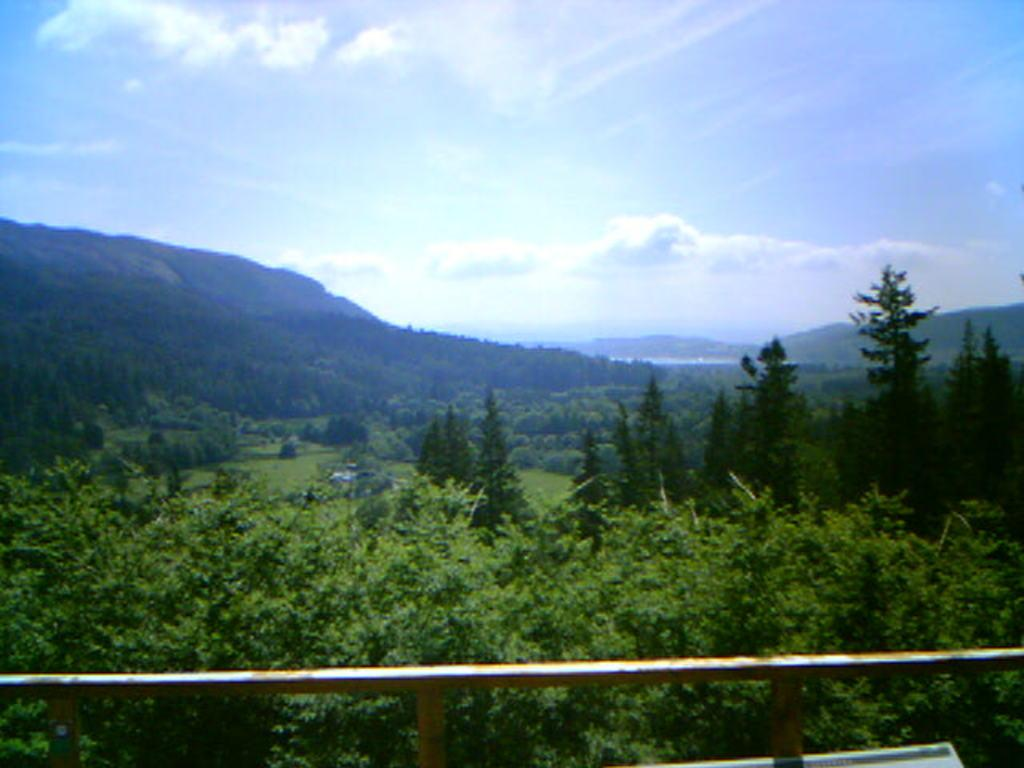What type of vegetation is present at the bottom of the image? There are trees on the bottom side of the image. What is visible at the top of the image? The sky is visible at the top of the image. What suggestion is being made by the flag in the image? There is no flag present in the image, so no suggestion can be made. What is the front of the image showing? The provided facts do not mention a front or any specific direction, so it is not possible to determine what the front of the image is showing. 